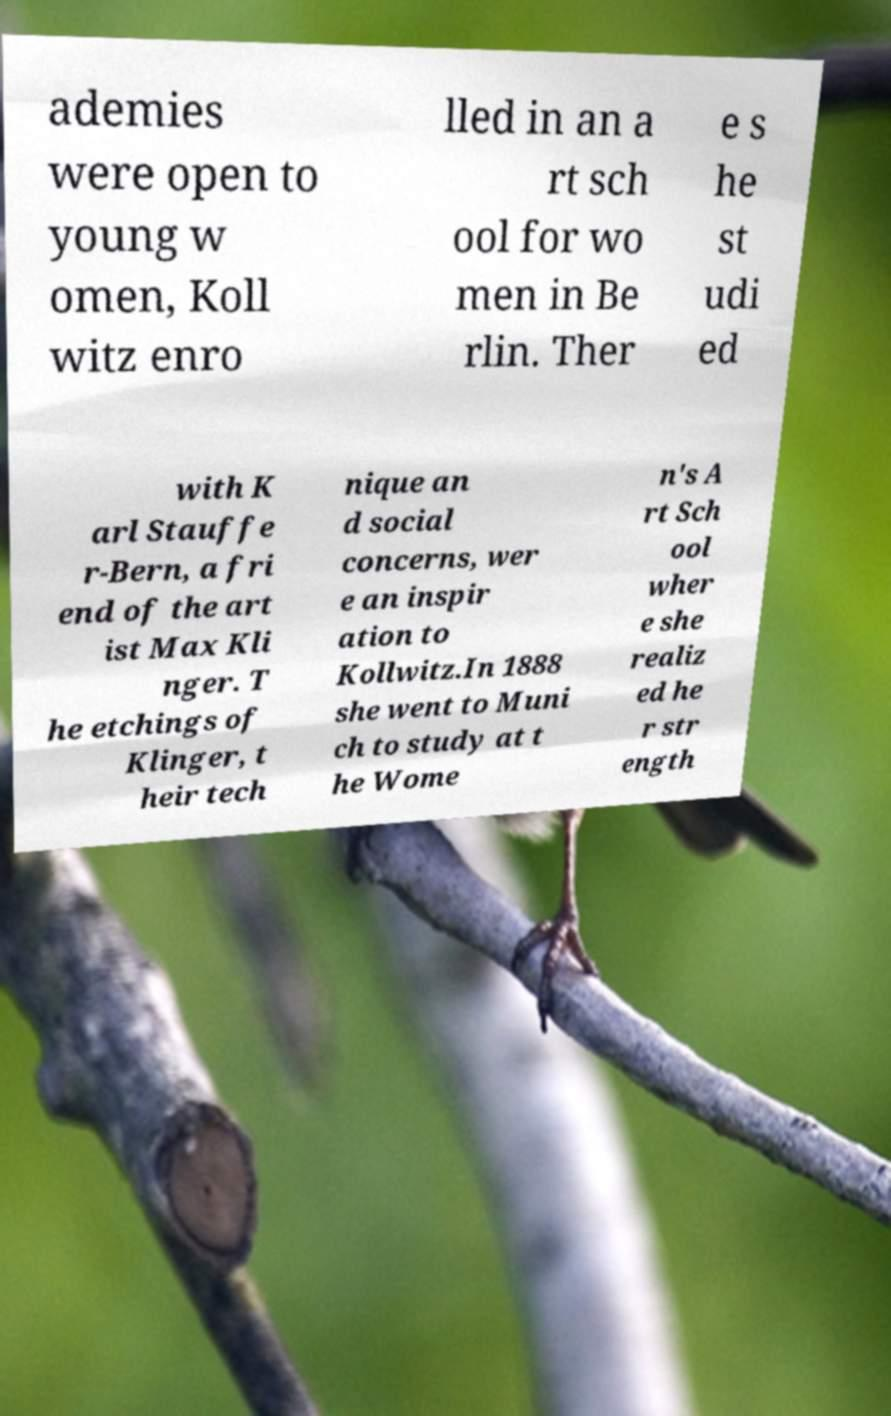Could you assist in decoding the text presented in this image and type it out clearly? ademies were open to young w omen, Koll witz enro lled in an a rt sch ool for wo men in Be rlin. Ther e s he st udi ed with K arl Stauffe r-Bern, a fri end of the art ist Max Kli nger. T he etchings of Klinger, t heir tech nique an d social concerns, wer e an inspir ation to Kollwitz.In 1888 she went to Muni ch to study at t he Wome n's A rt Sch ool wher e she realiz ed he r str ength 